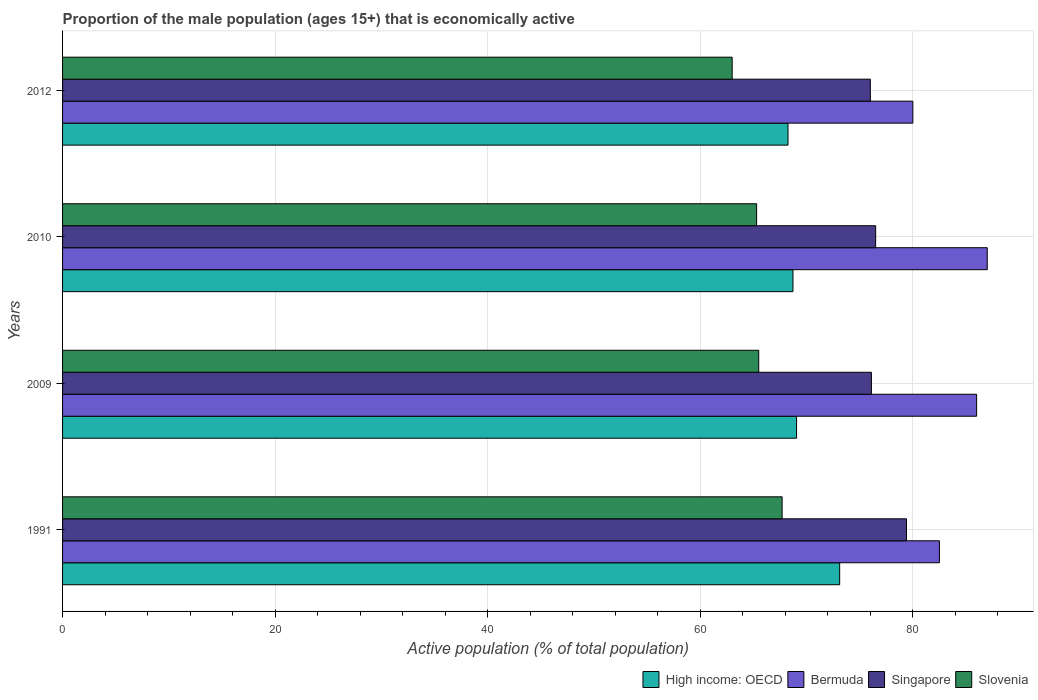Are the number of bars per tick equal to the number of legend labels?
Provide a short and direct response. Yes. How many bars are there on the 3rd tick from the top?
Make the answer very short. 4. How many bars are there on the 4th tick from the bottom?
Offer a terse response. 4. What is the label of the 1st group of bars from the top?
Keep it short and to the point. 2012. What is the proportion of the male population that is economically active in High income: OECD in 2009?
Provide a succinct answer. 69.06. Across all years, what is the maximum proportion of the male population that is economically active in Singapore?
Your answer should be compact. 79.4. Across all years, what is the minimum proportion of the male population that is economically active in High income: OECD?
Keep it short and to the point. 68.25. What is the total proportion of the male population that is economically active in Bermuda in the graph?
Provide a short and direct response. 335.5. What is the difference between the proportion of the male population that is economically active in Singapore in 2009 and that in 2012?
Make the answer very short. 0.1. What is the difference between the proportion of the male population that is economically active in Slovenia in 2010 and the proportion of the male population that is economically active in Bermuda in 1991?
Provide a succinct answer. -17.2. What is the average proportion of the male population that is economically active in Singapore per year?
Give a very brief answer. 77. In the year 2009, what is the difference between the proportion of the male population that is economically active in Slovenia and proportion of the male population that is economically active in High income: OECD?
Offer a very short reply. -3.56. In how many years, is the proportion of the male population that is economically active in Singapore greater than 40 %?
Offer a very short reply. 4. What is the ratio of the proportion of the male population that is economically active in Slovenia in 2009 to that in 2012?
Your answer should be compact. 1.04. Is the proportion of the male population that is economically active in Slovenia in 1991 less than that in 2012?
Ensure brevity in your answer.  No. What is the difference between the highest and the lowest proportion of the male population that is economically active in Slovenia?
Your answer should be compact. 4.7. What does the 1st bar from the top in 2009 represents?
Provide a short and direct response. Slovenia. What does the 4th bar from the bottom in 2009 represents?
Your answer should be compact. Slovenia. How many bars are there?
Your answer should be compact. 16. How many years are there in the graph?
Provide a succinct answer. 4. Does the graph contain grids?
Make the answer very short. Yes. What is the title of the graph?
Your response must be concise. Proportion of the male population (ages 15+) that is economically active. What is the label or title of the X-axis?
Make the answer very short. Active population (% of total population). What is the Active population (% of total population) in High income: OECD in 1991?
Make the answer very short. 73.11. What is the Active population (% of total population) in Bermuda in 1991?
Offer a terse response. 82.5. What is the Active population (% of total population) in Singapore in 1991?
Offer a terse response. 79.4. What is the Active population (% of total population) of Slovenia in 1991?
Make the answer very short. 67.7. What is the Active population (% of total population) of High income: OECD in 2009?
Your answer should be very brief. 69.06. What is the Active population (% of total population) of Singapore in 2009?
Ensure brevity in your answer.  76.1. What is the Active population (% of total population) of Slovenia in 2009?
Provide a short and direct response. 65.5. What is the Active population (% of total population) in High income: OECD in 2010?
Your response must be concise. 68.72. What is the Active population (% of total population) of Bermuda in 2010?
Give a very brief answer. 87. What is the Active population (% of total population) in Singapore in 2010?
Provide a short and direct response. 76.5. What is the Active population (% of total population) of Slovenia in 2010?
Offer a terse response. 65.3. What is the Active population (% of total population) in High income: OECD in 2012?
Provide a succinct answer. 68.25. What is the Active population (% of total population) of Slovenia in 2012?
Your response must be concise. 63. Across all years, what is the maximum Active population (% of total population) of High income: OECD?
Ensure brevity in your answer.  73.11. Across all years, what is the maximum Active population (% of total population) in Bermuda?
Your answer should be compact. 87. Across all years, what is the maximum Active population (% of total population) in Singapore?
Offer a very short reply. 79.4. Across all years, what is the maximum Active population (% of total population) in Slovenia?
Offer a terse response. 67.7. Across all years, what is the minimum Active population (% of total population) in High income: OECD?
Offer a very short reply. 68.25. Across all years, what is the minimum Active population (% of total population) in Bermuda?
Your answer should be very brief. 80. What is the total Active population (% of total population) in High income: OECD in the graph?
Give a very brief answer. 279.14. What is the total Active population (% of total population) of Bermuda in the graph?
Your response must be concise. 335.5. What is the total Active population (% of total population) in Singapore in the graph?
Keep it short and to the point. 308. What is the total Active population (% of total population) in Slovenia in the graph?
Your answer should be compact. 261.5. What is the difference between the Active population (% of total population) of High income: OECD in 1991 and that in 2009?
Make the answer very short. 4.06. What is the difference between the Active population (% of total population) in Singapore in 1991 and that in 2009?
Keep it short and to the point. 3.3. What is the difference between the Active population (% of total population) of Slovenia in 1991 and that in 2009?
Ensure brevity in your answer.  2.2. What is the difference between the Active population (% of total population) of High income: OECD in 1991 and that in 2010?
Offer a very short reply. 4.39. What is the difference between the Active population (% of total population) in Bermuda in 1991 and that in 2010?
Provide a succinct answer. -4.5. What is the difference between the Active population (% of total population) in Singapore in 1991 and that in 2010?
Ensure brevity in your answer.  2.9. What is the difference between the Active population (% of total population) of Slovenia in 1991 and that in 2010?
Ensure brevity in your answer.  2.4. What is the difference between the Active population (% of total population) in High income: OECD in 1991 and that in 2012?
Your response must be concise. 4.86. What is the difference between the Active population (% of total population) in Singapore in 1991 and that in 2012?
Your answer should be compact. 3.4. What is the difference between the Active population (% of total population) of High income: OECD in 2009 and that in 2010?
Offer a terse response. 0.34. What is the difference between the Active population (% of total population) of High income: OECD in 2009 and that in 2012?
Keep it short and to the point. 0.81. What is the difference between the Active population (% of total population) in Bermuda in 2009 and that in 2012?
Keep it short and to the point. 6. What is the difference between the Active population (% of total population) of Slovenia in 2009 and that in 2012?
Your response must be concise. 2.5. What is the difference between the Active population (% of total population) in High income: OECD in 2010 and that in 2012?
Your answer should be compact. 0.47. What is the difference between the Active population (% of total population) in Bermuda in 2010 and that in 2012?
Give a very brief answer. 7. What is the difference between the Active population (% of total population) in High income: OECD in 1991 and the Active population (% of total population) in Bermuda in 2009?
Make the answer very short. -12.89. What is the difference between the Active population (% of total population) in High income: OECD in 1991 and the Active population (% of total population) in Singapore in 2009?
Offer a terse response. -2.99. What is the difference between the Active population (% of total population) in High income: OECD in 1991 and the Active population (% of total population) in Slovenia in 2009?
Give a very brief answer. 7.61. What is the difference between the Active population (% of total population) in Bermuda in 1991 and the Active population (% of total population) in Singapore in 2009?
Your answer should be very brief. 6.4. What is the difference between the Active population (% of total population) in Bermuda in 1991 and the Active population (% of total population) in Slovenia in 2009?
Provide a succinct answer. 17. What is the difference between the Active population (% of total population) in High income: OECD in 1991 and the Active population (% of total population) in Bermuda in 2010?
Make the answer very short. -13.89. What is the difference between the Active population (% of total population) in High income: OECD in 1991 and the Active population (% of total population) in Singapore in 2010?
Keep it short and to the point. -3.39. What is the difference between the Active population (% of total population) in High income: OECD in 1991 and the Active population (% of total population) in Slovenia in 2010?
Offer a very short reply. 7.81. What is the difference between the Active population (% of total population) in Bermuda in 1991 and the Active population (% of total population) in Slovenia in 2010?
Ensure brevity in your answer.  17.2. What is the difference between the Active population (% of total population) of Singapore in 1991 and the Active population (% of total population) of Slovenia in 2010?
Keep it short and to the point. 14.1. What is the difference between the Active population (% of total population) in High income: OECD in 1991 and the Active population (% of total population) in Bermuda in 2012?
Provide a succinct answer. -6.89. What is the difference between the Active population (% of total population) of High income: OECD in 1991 and the Active population (% of total population) of Singapore in 2012?
Your answer should be compact. -2.89. What is the difference between the Active population (% of total population) of High income: OECD in 1991 and the Active population (% of total population) of Slovenia in 2012?
Provide a short and direct response. 10.11. What is the difference between the Active population (% of total population) of Bermuda in 1991 and the Active population (% of total population) of Singapore in 2012?
Provide a short and direct response. 6.5. What is the difference between the Active population (% of total population) of Bermuda in 1991 and the Active population (% of total population) of Slovenia in 2012?
Ensure brevity in your answer.  19.5. What is the difference between the Active population (% of total population) of Singapore in 1991 and the Active population (% of total population) of Slovenia in 2012?
Your response must be concise. 16.4. What is the difference between the Active population (% of total population) of High income: OECD in 2009 and the Active population (% of total population) of Bermuda in 2010?
Your response must be concise. -17.94. What is the difference between the Active population (% of total population) of High income: OECD in 2009 and the Active population (% of total population) of Singapore in 2010?
Keep it short and to the point. -7.44. What is the difference between the Active population (% of total population) of High income: OECD in 2009 and the Active population (% of total population) of Slovenia in 2010?
Give a very brief answer. 3.76. What is the difference between the Active population (% of total population) of Bermuda in 2009 and the Active population (% of total population) of Slovenia in 2010?
Your answer should be very brief. 20.7. What is the difference between the Active population (% of total population) of High income: OECD in 2009 and the Active population (% of total population) of Bermuda in 2012?
Keep it short and to the point. -10.94. What is the difference between the Active population (% of total population) in High income: OECD in 2009 and the Active population (% of total population) in Singapore in 2012?
Your response must be concise. -6.94. What is the difference between the Active population (% of total population) of High income: OECD in 2009 and the Active population (% of total population) of Slovenia in 2012?
Make the answer very short. 6.06. What is the difference between the Active population (% of total population) in Bermuda in 2009 and the Active population (% of total population) in Singapore in 2012?
Your answer should be very brief. 10. What is the difference between the Active population (% of total population) in High income: OECD in 2010 and the Active population (% of total population) in Bermuda in 2012?
Provide a short and direct response. -11.28. What is the difference between the Active population (% of total population) in High income: OECD in 2010 and the Active population (% of total population) in Singapore in 2012?
Your answer should be very brief. -7.28. What is the difference between the Active population (% of total population) in High income: OECD in 2010 and the Active population (% of total population) in Slovenia in 2012?
Provide a short and direct response. 5.72. What is the difference between the Active population (% of total population) in Bermuda in 2010 and the Active population (% of total population) in Slovenia in 2012?
Offer a very short reply. 24. What is the average Active population (% of total population) of High income: OECD per year?
Offer a terse response. 69.79. What is the average Active population (% of total population) in Bermuda per year?
Your answer should be very brief. 83.88. What is the average Active population (% of total population) of Slovenia per year?
Give a very brief answer. 65.38. In the year 1991, what is the difference between the Active population (% of total population) in High income: OECD and Active population (% of total population) in Bermuda?
Provide a succinct answer. -9.39. In the year 1991, what is the difference between the Active population (% of total population) of High income: OECD and Active population (% of total population) of Singapore?
Your response must be concise. -6.29. In the year 1991, what is the difference between the Active population (% of total population) of High income: OECD and Active population (% of total population) of Slovenia?
Your answer should be compact. 5.41. In the year 1991, what is the difference between the Active population (% of total population) of Bermuda and Active population (% of total population) of Singapore?
Your answer should be compact. 3.1. In the year 1991, what is the difference between the Active population (% of total population) in Bermuda and Active population (% of total population) in Slovenia?
Your response must be concise. 14.8. In the year 2009, what is the difference between the Active population (% of total population) of High income: OECD and Active population (% of total population) of Bermuda?
Your answer should be compact. -16.94. In the year 2009, what is the difference between the Active population (% of total population) of High income: OECD and Active population (% of total population) of Singapore?
Offer a terse response. -7.04. In the year 2009, what is the difference between the Active population (% of total population) of High income: OECD and Active population (% of total population) of Slovenia?
Give a very brief answer. 3.56. In the year 2009, what is the difference between the Active population (% of total population) in Bermuda and Active population (% of total population) in Singapore?
Ensure brevity in your answer.  9.9. In the year 2009, what is the difference between the Active population (% of total population) of Singapore and Active population (% of total population) of Slovenia?
Your answer should be very brief. 10.6. In the year 2010, what is the difference between the Active population (% of total population) in High income: OECD and Active population (% of total population) in Bermuda?
Your answer should be very brief. -18.28. In the year 2010, what is the difference between the Active population (% of total population) of High income: OECD and Active population (% of total population) of Singapore?
Ensure brevity in your answer.  -7.78. In the year 2010, what is the difference between the Active population (% of total population) in High income: OECD and Active population (% of total population) in Slovenia?
Provide a short and direct response. 3.42. In the year 2010, what is the difference between the Active population (% of total population) in Bermuda and Active population (% of total population) in Singapore?
Your response must be concise. 10.5. In the year 2010, what is the difference between the Active population (% of total population) in Bermuda and Active population (% of total population) in Slovenia?
Your answer should be very brief. 21.7. In the year 2012, what is the difference between the Active population (% of total population) in High income: OECD and Active population (% of total population) in Bermuda?
Give a very brief answer. -11.75. In the year 2012, what is the difference between the Active population (% of total population) of High income: OECD and Active population (% of total population) of Singapore?
Offer a terse response. -7.75. In the year 2012, what is the difference between the Active population (% of total population) in High income: OECD and Active population (% of total population) in Slovenia?
Make the answer very short. 5.25. In the year 2012, what is the difference between the Active population (% of total population) of Bermuda and Active population (% of total population) of Singapore?
Your answer should be very brief. 4. In the year 2012, what is the difference between the Active population (% of total population) of Bermuda and Active population (% of total population) of Slovenia?
Provide a short and direct response. 17. What is the ratio of the Active population (% of total population) in High income: OECD in 1991 to that in 2009?
Your response must be concise. 1.06. What is the ratio of the Active population (% of total population) of Bermuda in 1991 to that in 2009?
Your answer should be compact. 0.96. What is the ratio of the Active population (% of total population) of Singapore in 1991 to that in 2009?
Your answer should be very brief. 1.04. What is the ratio of the Active population (% of total population) in Slovenia in 1991 to that in 2009?
Your response must be concise. 1.03. What is the ratio of the Active population (% of total population) in High income: OECD in 1991 to that in 2010?
Your answer should be very brief. 1.06. What is the ratio of the Active population (% of total population) of Bermuda in 1991 to that in 2010?
Offer a terse response. 0.95. What is the ratio of the Active population (% of total population) in Singapore in 1991 to that in 2010?
Give a very brief answer. 1.04. What is the ratio of the Active population (% of total population) in Slovenia in 1991 to that in 2010?
Offer a terse response. 1.04. What is the ratio of the Active population (% of total population) of High income: OECD in 1991 to that in 2012?
Provide a succinct answer. 1.07. What is the ratio of the Active population (% of total population) of Bermuda in 1991 to that in 2012?
Provide a short and direct response. 1.03. What is the ratio of the Active population (% of total population) in Singapore in 1991 to that in 2012?
Provide a short and direct response. 1.04. What is the ratio of the Active population (% of total population) in Slovenia in 1991 to that in 2012?
Ensure brevity in your answer.  1.07. What is the ratio of the Active population (% of total population) in Bermuda in 2009 to that in 2010?
Offer a terse response. 0.99. What is the ratio of the Active population (% of total population) in Singapore in 2009 to that in 2010?
Your response must be concise. 0.99. What is the ratio of the Active population (% of total population) in High income: OECD in 2009 to that in 2012?
Provide a succinct answer. 1.01. What is the ratio of the Active population (% of total population) in Bermuda in 2009 to that in 2012?
Keep it short and to the point. 1.07. What is the ratio of the Active population (% of total population) of Slovenia in 2009 to that in 2012?
Offer a terse response. 1.04. What is the ratio of the Active population (% of total population) of High income: OECD in 2010 to that in 2012?
Your response must be concise. 1.01. What is the ratio of the Active population (% of total population) in Bermuda in 2010 to that in 2012?
Your response must be concise. 1.09. What is the ratio of the Active population (% of total population) of Singapore in 2010 to that in 2012?
Your answer should be compact. 1.01. What is the ratio of the Active population (% of total population) of Slovenia in 2010 to that in 2012?
Offer a terse response. 1.04. What is the difference between the highest and the second highest Active population (% of total population) of High income: OECD?
Offer a very short reply. 4.06. What is the difference between the highest and the second highest Active population (% of total population) of Bermuda?
Your response must be concise. 1. What is the difference between the highest and the second highest Active population (% of total population) of Singapore?
Provide a succinct answer. 2.9. What is the difference between the highest and the lowest Active population (% of total population) of High income: OECD?
Offer a terse response. 4.86. What is the difference between the highest and the lowest Active population (% of total population) in Singapore?
Ensure brevity in your answer.  3.4. 